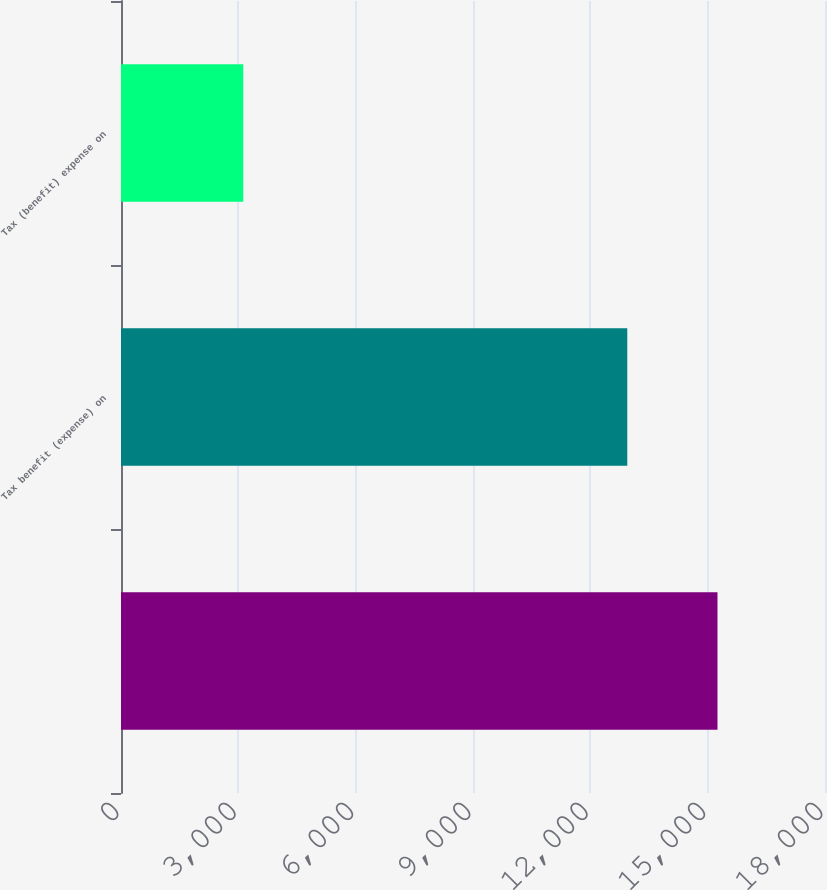Convert chart to OTSL. <chart><loc_0><loc_0><loc_500><loc_500><bar_chart><ecel><fcel>Tax benefit (expense) on<fcel>Tax (benefit) expense on<nl><fcel>15251<fcel>12945<fcel>3125.4<nl></chart> 